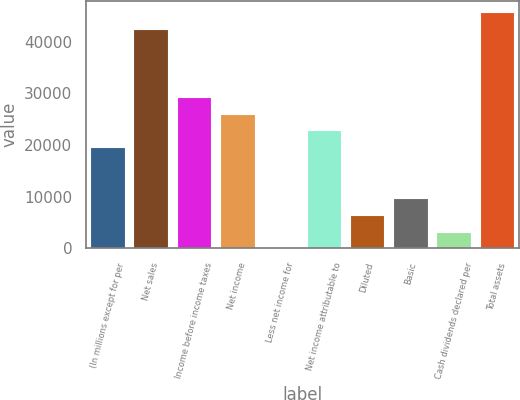<chart> <loc_0><loc_0><loc_500><loc_500><bar_chart><fcel>(In millions except for per<fcel>Net sales<fcel>Income before income taxes<fcel>Net income<fcel>Less net income for<fcel>Net income attributable to<fcel>Diluted<fcel>Basic<fcel>Cash dividends declared per<fcel>Total assets<nl><fcel>19574.2<fcel>42409.6<fcel>29360.8<fcel>26098.6<fcel>1<fcel>22836.4<fcel>6525.4<fcel>9787.6<fcel>3263.2<fcel>45671.8<nl></chart> 